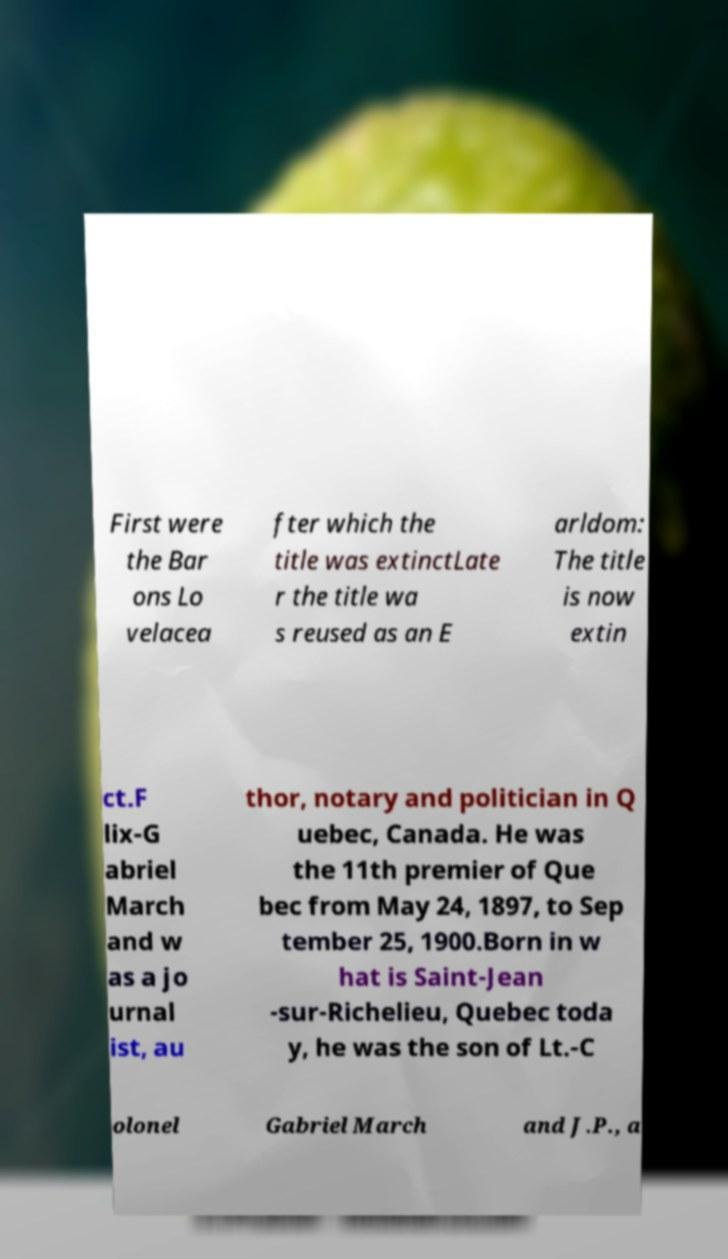Can you read and provide the text displayed in the image?This photo seems to have some interesting text. Can you extract and type it out for me? First were the Bar ons Lo velacea fter which the title was extinctLate r the title wa s reused as an E arldom: The title is now extin ct.F lix-G abriel March and w as a jo urnal ist, au thor, notary and politician in Q uebec, Canada. He was the 11th premier of Que bec from May 24, 1897, to Sep tember 25, 1900.Born in w hat is Saint-Jean -sur-Richelieu, Quebec toda y, he was the son of Lt.-C olonel Gabriel March and J.P., a 